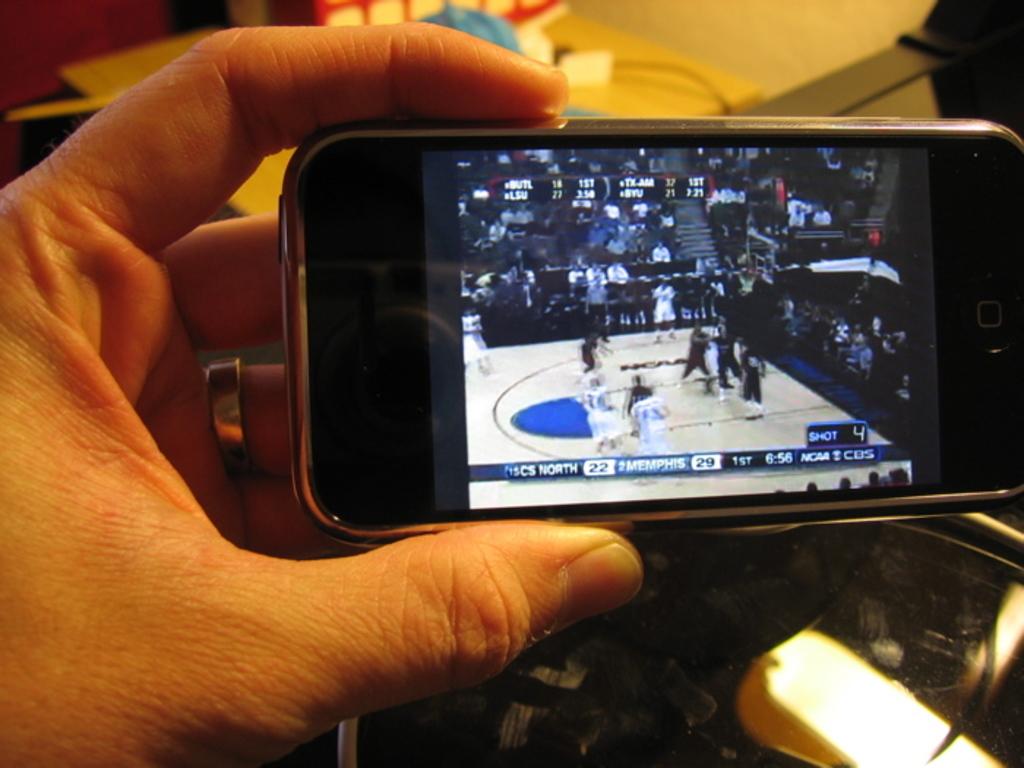How many points does memphis have?
Ensure brevity in your answer.  29. What is the score?
Provide a succinct answer. 22-29. 